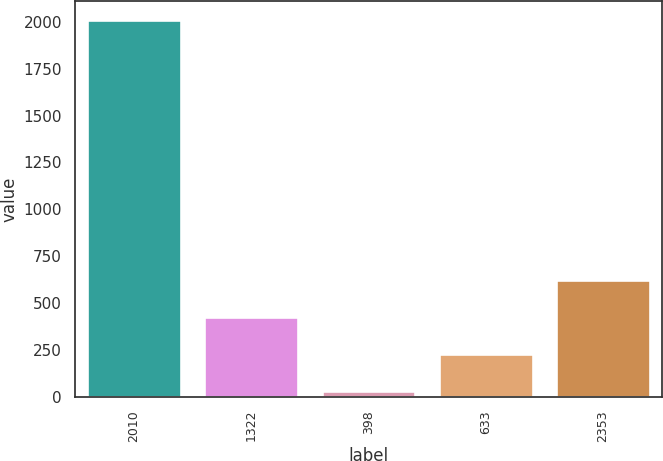Convert chart to OTSL. <chart><loc_0><loc_0><loc_500><loc_500><bar_chart><fcel>2010<fcel>1322<fcel>398<fcel>633<fcel>2353<nl><fcel>2008<fcel>425.84<fcel>30.3<fcel>228.07<fcel>623.61<nl></chart> 